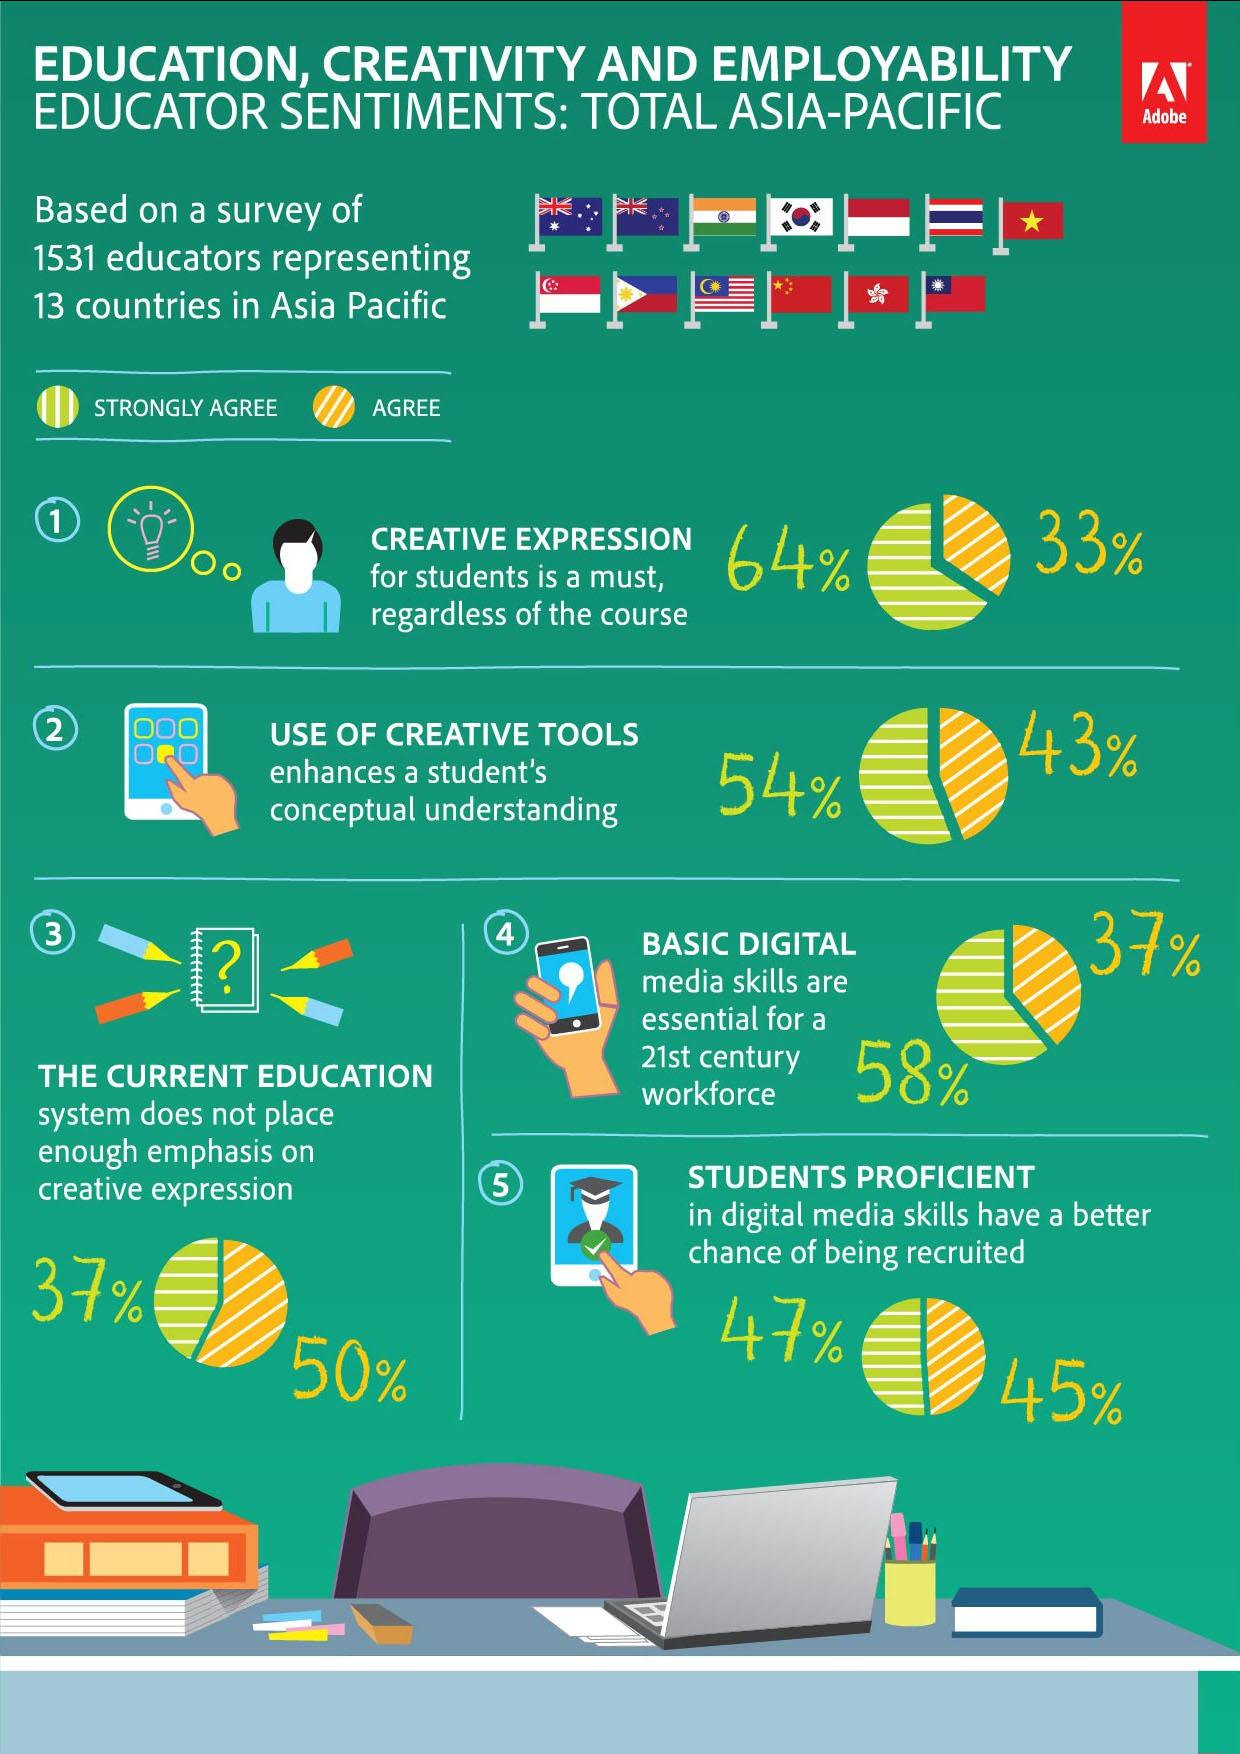Draw attention to some important aspects in this diagram. The flag of the Asian country that is shown in the third position is India. According to the survey, 37% of educators strongly agree that the current education system needs to be changed in order to promote more creative expression. Of the survey, 5 questions/topics were considered in total. A survey of educators found that 54% strongly agreed that the use of creative tools enhances student understanding. In a survey of educators, 47% strongly agreed that students have proficiency in digital media skills and have a higher chance of getting recruited quickly. 